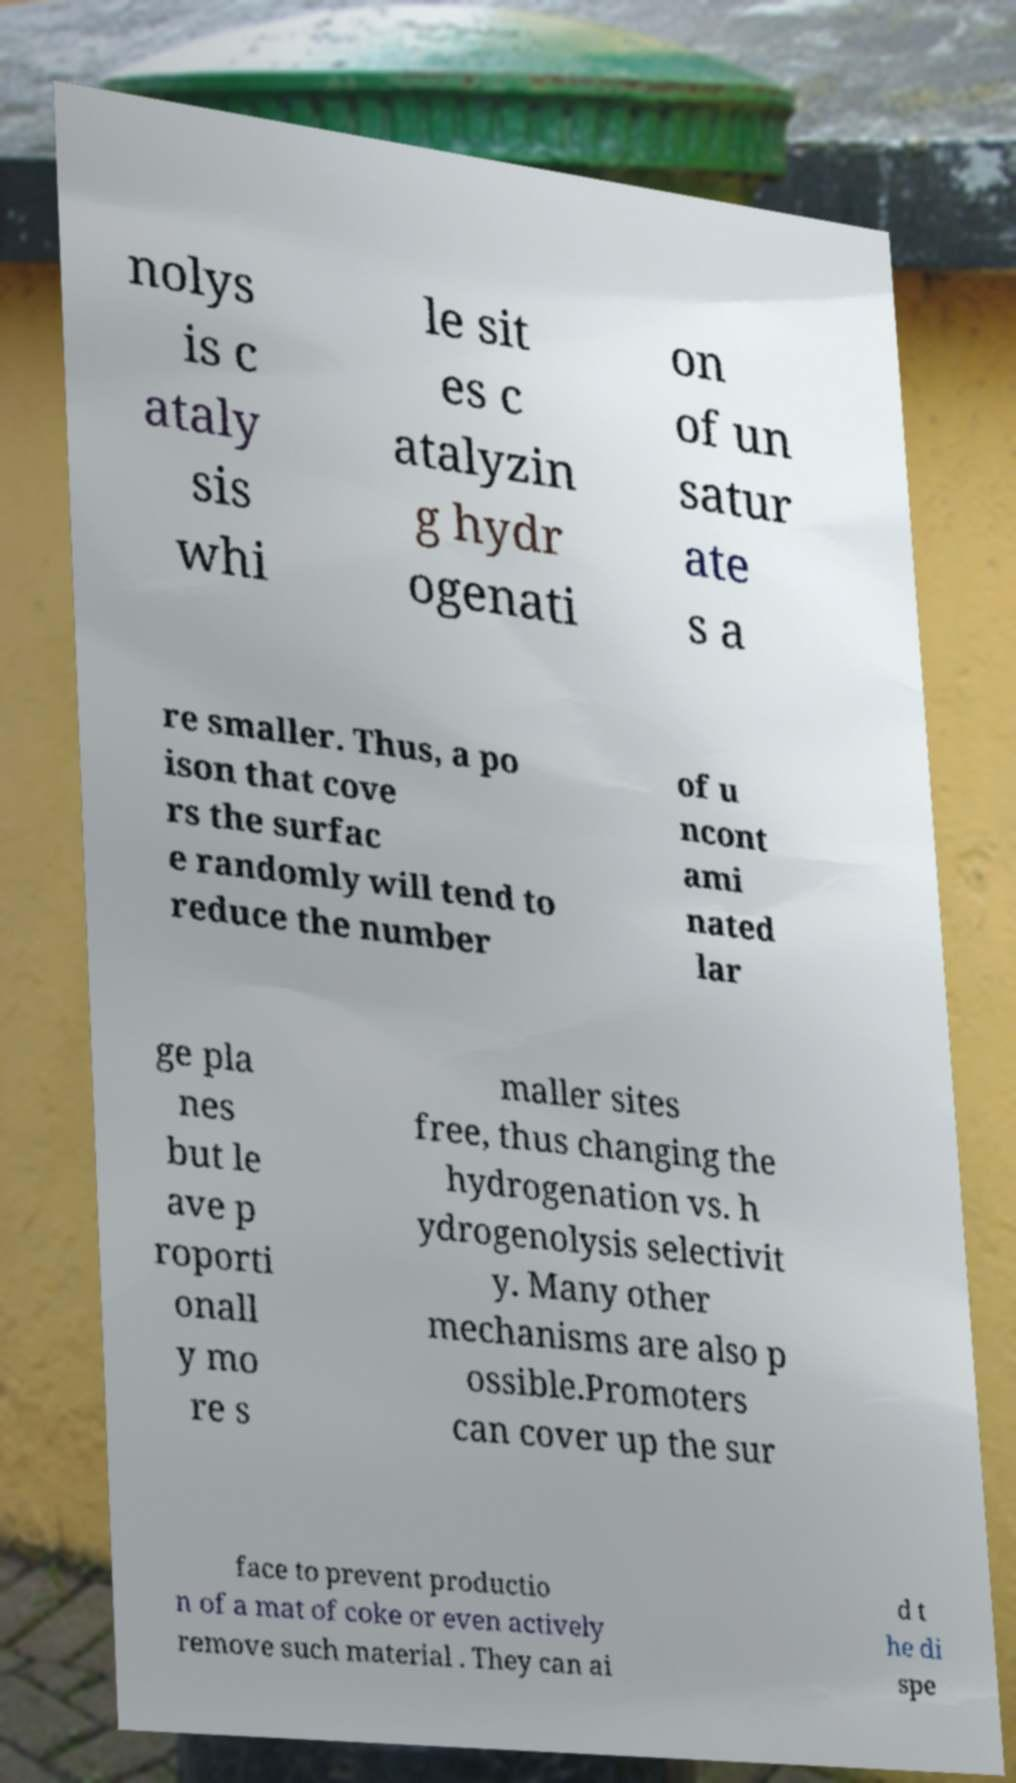I need the written content from this picture converted into text. Can you do that? nolys is c ataly sis whi le sit es c atalyzin g hydr ogenati on of un satur ate s a re smaller. Thus, a po ison that cove rs the surfac e randomly will tend to reduce the number of u ncont ami nated lar ge pla nes but le ave p roporti onall y mo re s maller sites free, thus changing the hydrogenation vs. h ydrogenolysis selectivit y. Many other mechanisms are also p ossible.Promoters can cover up the sur face to prevent productio n of a mat of coke or even actively remove such material . They can ai d t he di spe 